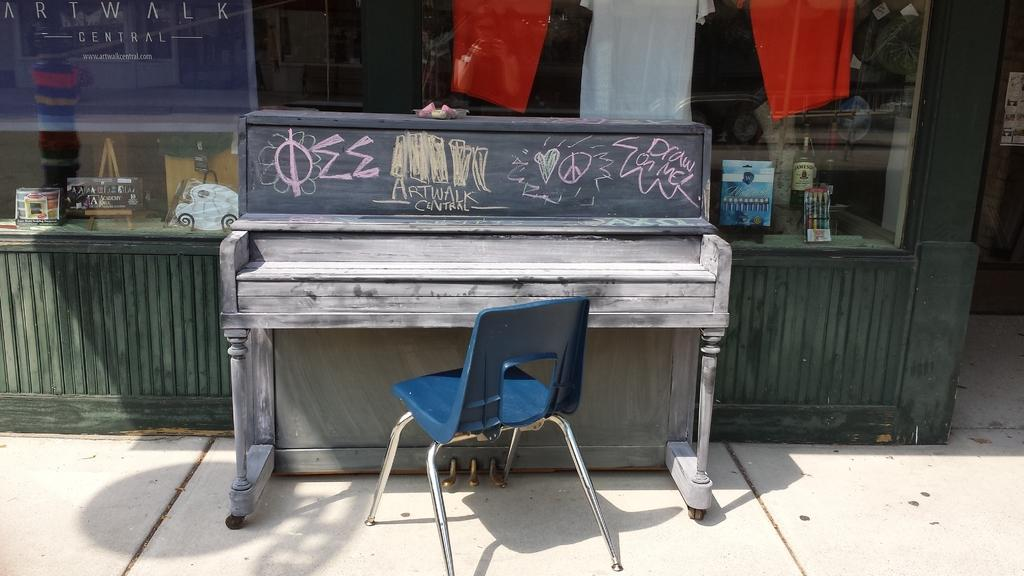What type of structure is present in the image? There is a building in the image. What else can be seen in the image besides the building? Clothes, a table, and a chair are visible in the image. What type of music is playing in the background of the image? There is no music present in the image; it only shows a building, clothes, a table, and a chair. 